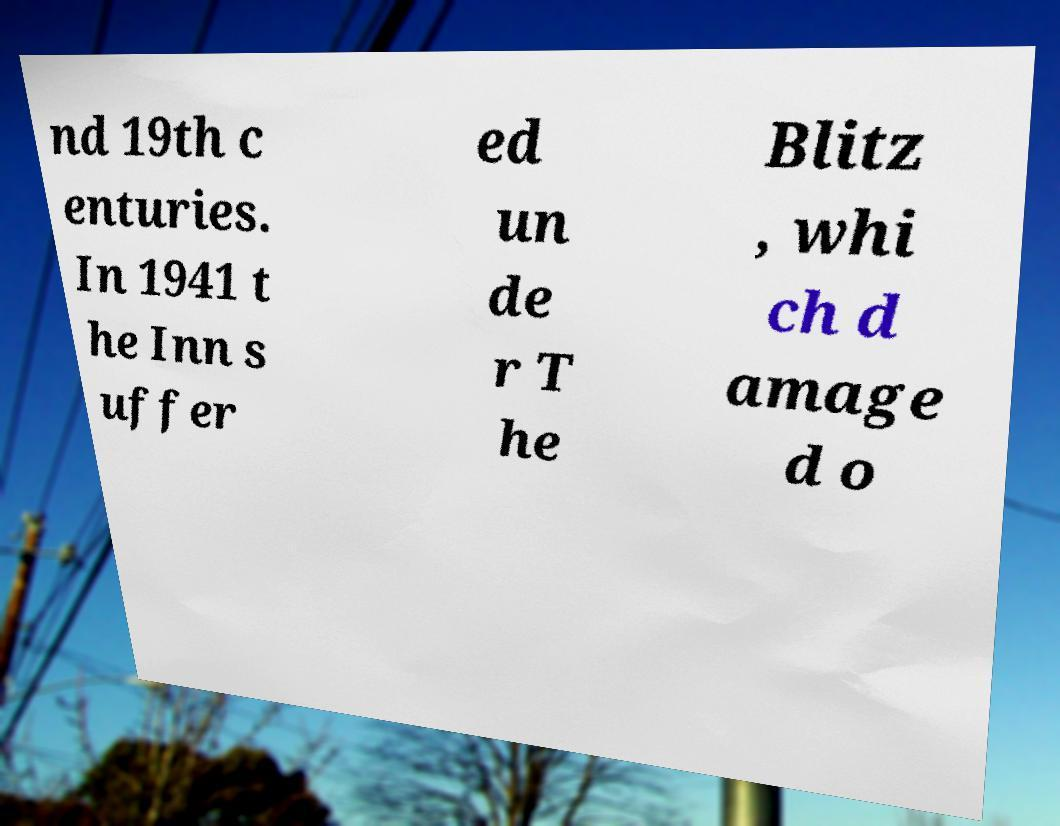Can you accurately transcribe the text from the provided image for me? nd 19th c enturies. In 1941 t he Inn s uffer ed un de r T he Blitz , whi ch d amage d o 